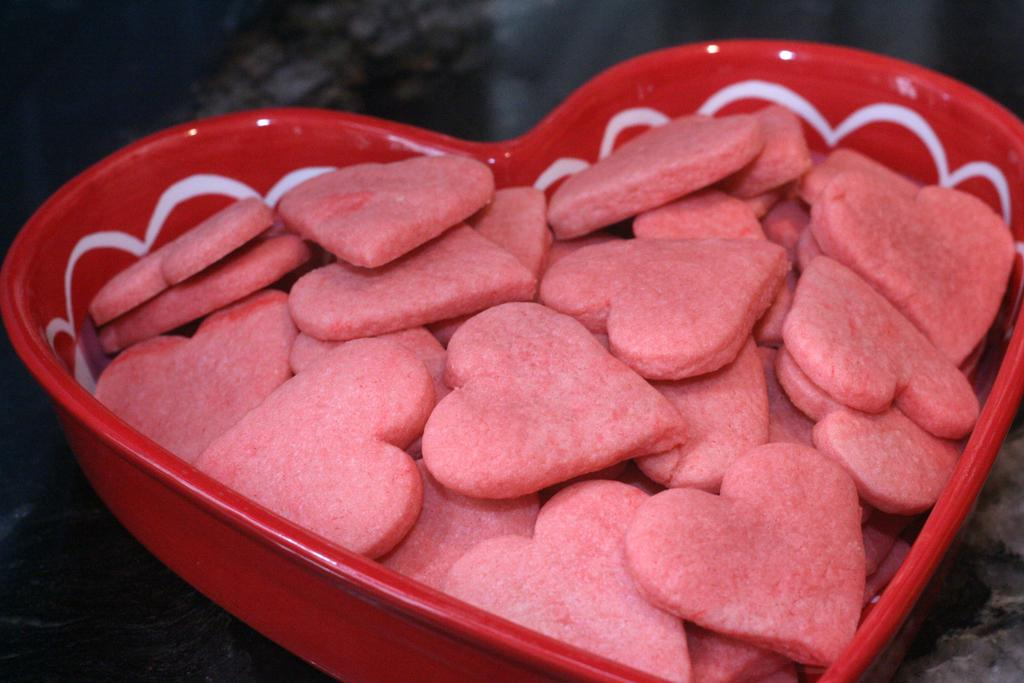What shape are the food items in the bowl in the image? The food items in the bowl are heart-shaped. Can you describe the background of the image? The background of the image is blurred. What type of book is visible in the image? There is no book present in the image. 